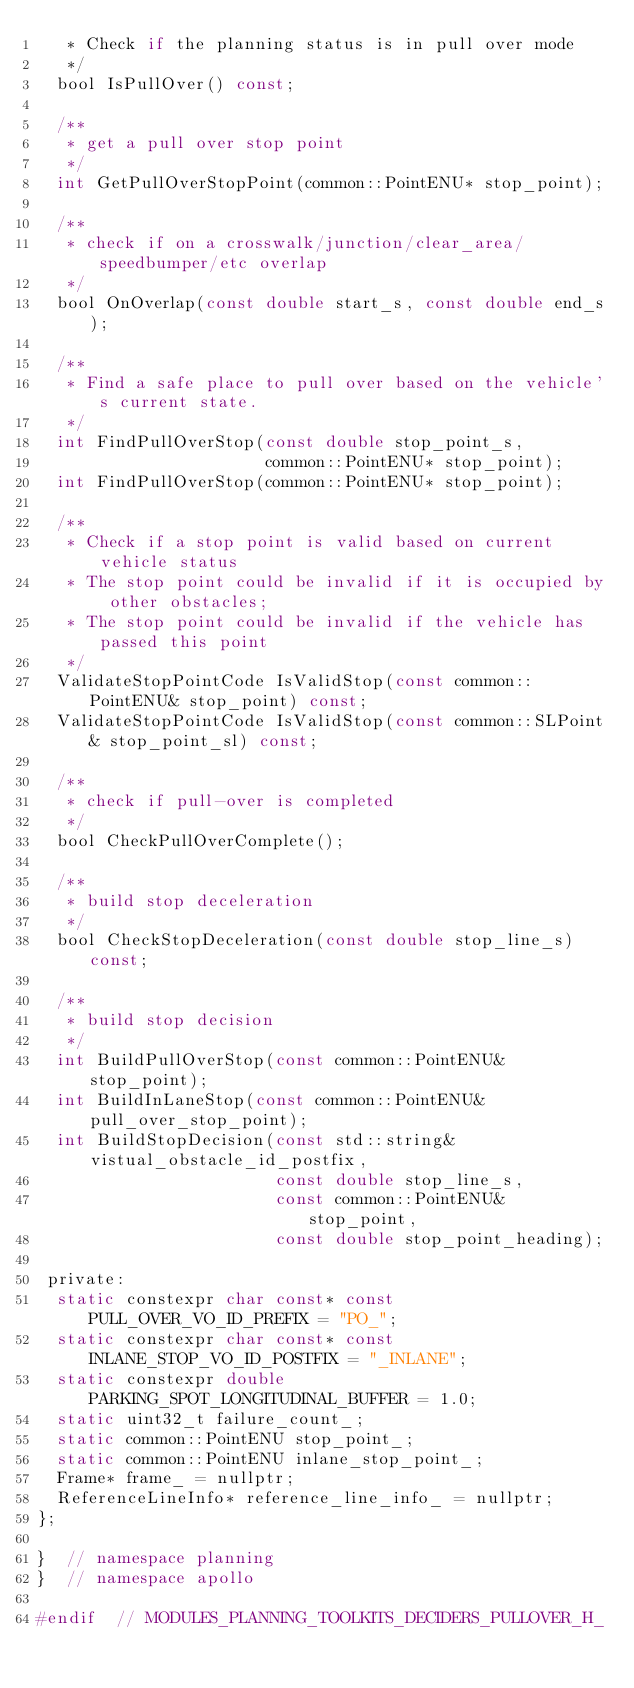Convert code to text. <code><loc_0><loc_0><loc_500><loc_500><_C_>   * Check if the planning status is in pull over mode
   */
  bool IsPullOver() const;

  /**
   * get a pull over stop point
   */
  int GetPullOverStopPoint(common::PointENU* stop_point);

  /**
   * check if on a crosswalk/junction/clear_area/speedbumper/etc overlap
   */
  bool OnOverlap(const double start_s, const double end_s);

  /**
   * Find a safe place to pull over based on the vehicle's current state.
   */
  int FindPullOverStop(const double stop_point_s,
                       common::PointENU* stop_point);
  int FindPullOverStop(common::PointENU* stop_point);

  /**
   * Check if a stop point is valid based on current vehicle status
   * The stop point could be invalid if it is occupied by other obstacles;
   * The stop point could be invalid if the vehicle has passed this point
   */
  ValidateStopPointCode IsValidStop(const common::PointENU& stop_point) const;
  ValidateStopPointCode IsValidStop(const common::SLPoint& stop_point_sl) const;

  /**
   * check if pull-over is completed
   */
  bool CheckPullOverComplete();

  /**
   * build stop deceleration
   */
  bool CheckStopDeceleration(const double stop_line_s) const;

  /**
   * build stop decision
   */
  int BuildPullOverStop(const common::PointENU& stop_point);
  int BuildInLaneStop(const common::PointENU& pull_over_stop_point);
  int BuildStopDecision(const std::string& vistual_obstacle_id_postfix,
                        const double stop_line_s,
                        const common::PointENU& stop_point,
                        const double stop_point_heading);

 private:
  static constexpr char const* const PULL_OVER_VO_ID_PREFIX = "PO_";
  static constexpr char const* const INLANE_STOP_VO_ID_POSTFIX = "_INLANE";
  static constexpr double PARKING_SPOT_LONGITUDINAL_BUFFER = 1.0;
  static uint32_t failure_count_;
  static common::PointENU stop_point_;
  static common::PointENU inlane_stop_point_;
  Frame* frame_ = nullptr;
  ReferenceLineInfo* reference_line_info_ = nullptr;
};

}  // namespace planning
}  // namespace apollo

#endif  // MODULES_PLANNING_TOOLKITS_DECIDERS_PULLOVER_H_
</code> 